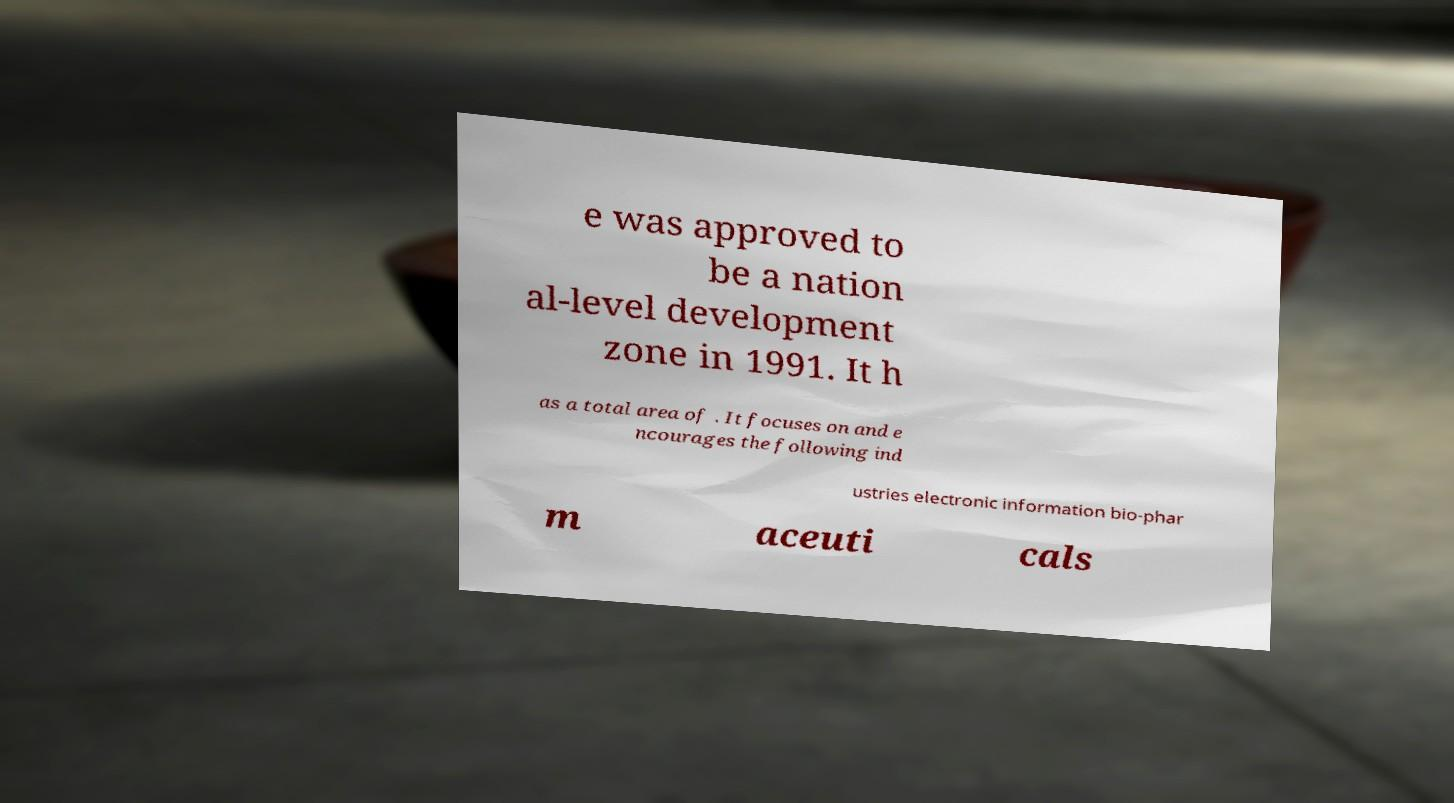What messages or text are displayed in this image? I need them in a readable, typed format. e was approved to be a nation al-level development zone in 1991. It h as a total area of . It focuses on and e ncourages the following ind ustries electronic information bio-phar m aceuti cals 